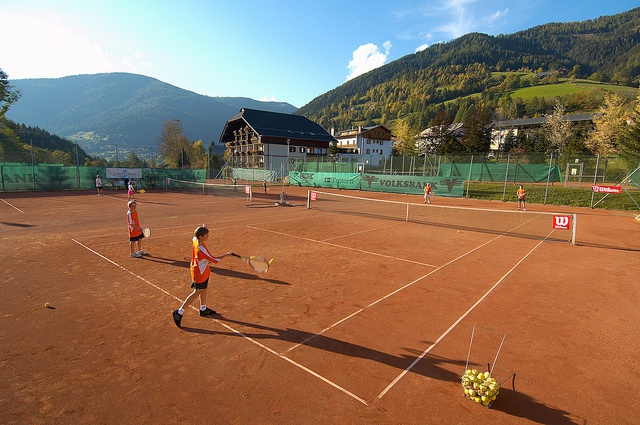Describe the objects in this image and their specific colors. I can see people in white, brown, black, and maroon tones, people in white, brown, and maroon tones, tennis racket in white, salmon, tan, and brown tones, people in white, brown, and red tones, and people in white, black, gray, maroon, and darkgray tones in this image. 